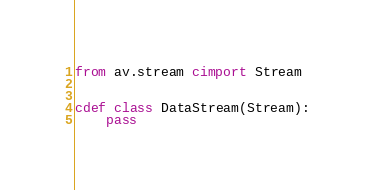Convert code to text. <code><loc_0><loc_0><loc_500><loc_500><_Cython_>
from av.stream cimport Stream


cdef class DataStream(Stream):
	pass
</code> 